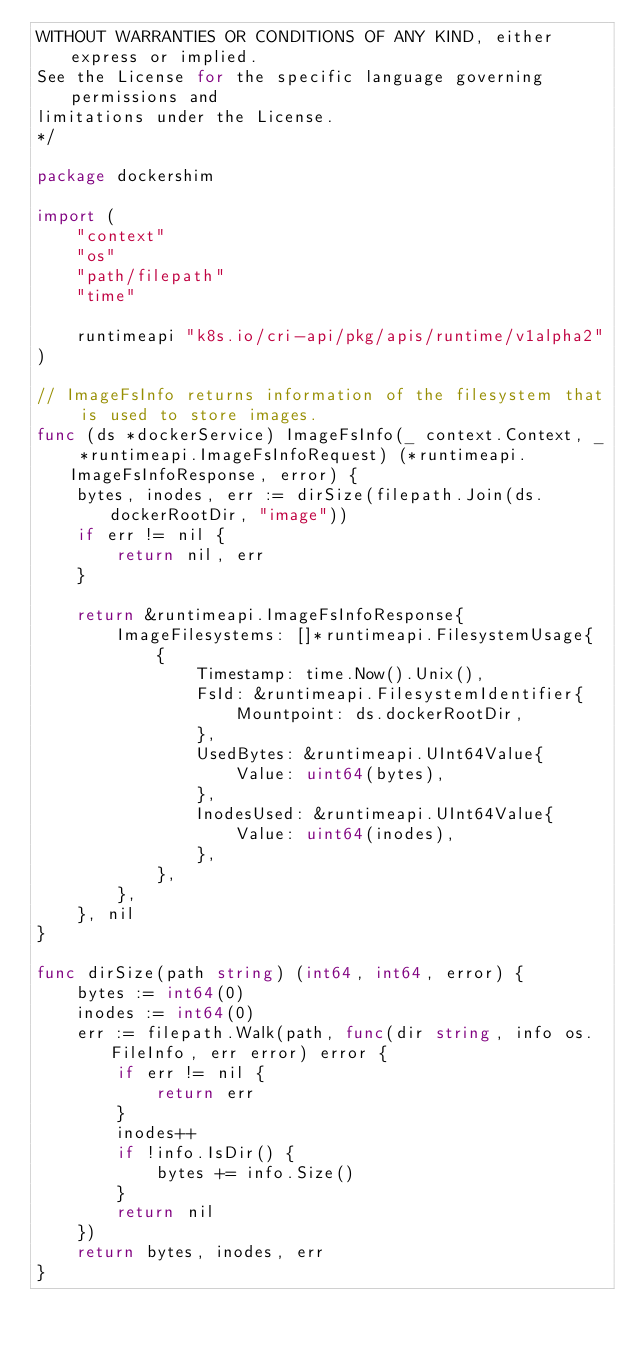<code> <loc_0><loc_0><loc_500><loc_500><_Go_>WITHOUT WARRANTIES OR CONDITIONS OF ANY KIND, either express or implied.
See the License for the specific language governing permissions and
limitations under the License.
*/

package dockershim

import (
	"context"
	"os"
	"path/filepath"
	"time"

	runtimeapi "k8s.io/cri-api/pkg/apis/runtime/v1alpha2"
)

// ImageFsInfo returns information of the filesystem that is used to store images.
func (ds *dockerService) ImageFsInfo(_ context.Context, _ *runtimeapi.ImageFsInfoRequest) (*runtimeapi.ImageFsInfoResponse, error) {
	bytes, inodes, err := dirSize(filepath.Join(ds.dockerRootDir, "image"))
	if err != nil {
		return nil, err
	}

	return &runtimeapi.ImageFsInfoResponse{
		ImageFilesystems: []*runtimeapi.FilesystemUsage{
			{
				Timestamp: time.Now().Unix(),
				FsId: &runtimeapi.FilesystemIdentifier{
					Mountpoint: ds.dockerRootDir,
				},
				UsedBytes: &runtimeapi.UInt64Value{
					Value: uint64(bytes),
				},
				InodesUsed: &runtimeapi.UInt64Value{
					Value: uint64(inodes),
				},
			},
		},
	}, nil
}

func dirSize(path string) (int64, int64, error) {
	bytes := int64(0)
	inodes := int64(0)
	err := filepath.Walk(path, func(dir string, info os.FileInfo, err error) error {
		if err != nil {
			return err
		}
		inodes++
		if !info.IsDir() {
			bytes += info.Size()
		}
		return nil
	})
	return bytes, inodes, err
}
</code> 